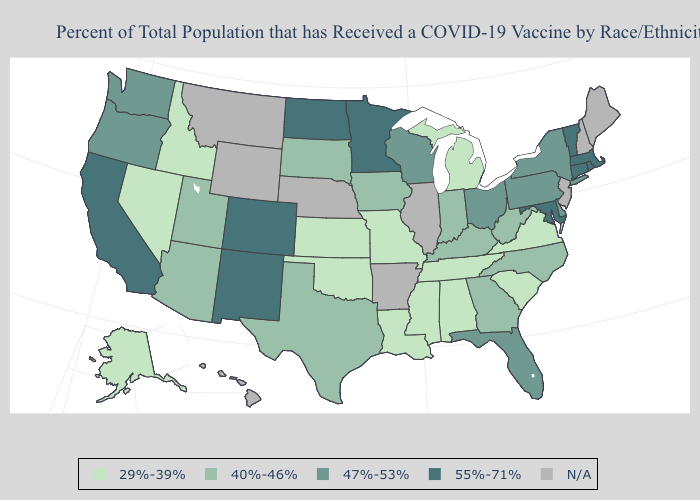What is the value of New Jersey?
Quick response, please. N/A. What is the lowest value in the USA?
Short answer required. 29%-39%. Does Wisconsin have the lowest value in the MidWest?
Give a very brief answer. No. What is the highest value in the West ?
Concise answer only. 55%-71%. Name the states that have a value in the range N/A?
Be succinct. Arkansas, Hawaii, Illinois, Maine, Montana, Nebraska, New Hampshire, New Jersey, Wyoming. What is the lowest value in the USA?
Be succinct. 29%-39%. What is the value of Oregon?
Keep it brief. 47%-53%. Which states have the lowest value in the MidWest?
Answer briefly. Kansas, Michigan, Missouri. Name the states that have a value in the range 40%-46%?
Keep it brief. Arizona, Georgia, Indiana, Iowa, Kentucky, North Carolina, South Dakota, Texas, Utah, West Virginia. What is the value of Rhode Island?
Write a very short answer. 55%-71%. Which states hav the highest value in the Northeast?
Be succinct. Connecticut, Massachusetts, Rhode Island, Vermont. Among the states that border Colorado , which have the lowest value?
Give a very brief answer. Kansas, Oklahoma. How many symbols are there in the legend?
Keep it brief. 5. What is the value of Utah?
Write a very short answer. 40%-46%. 